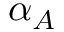Convert formula to latex. <formula><loc_0><loc_0><loc_500><loc_500>\alpha _ { A }</formula> 